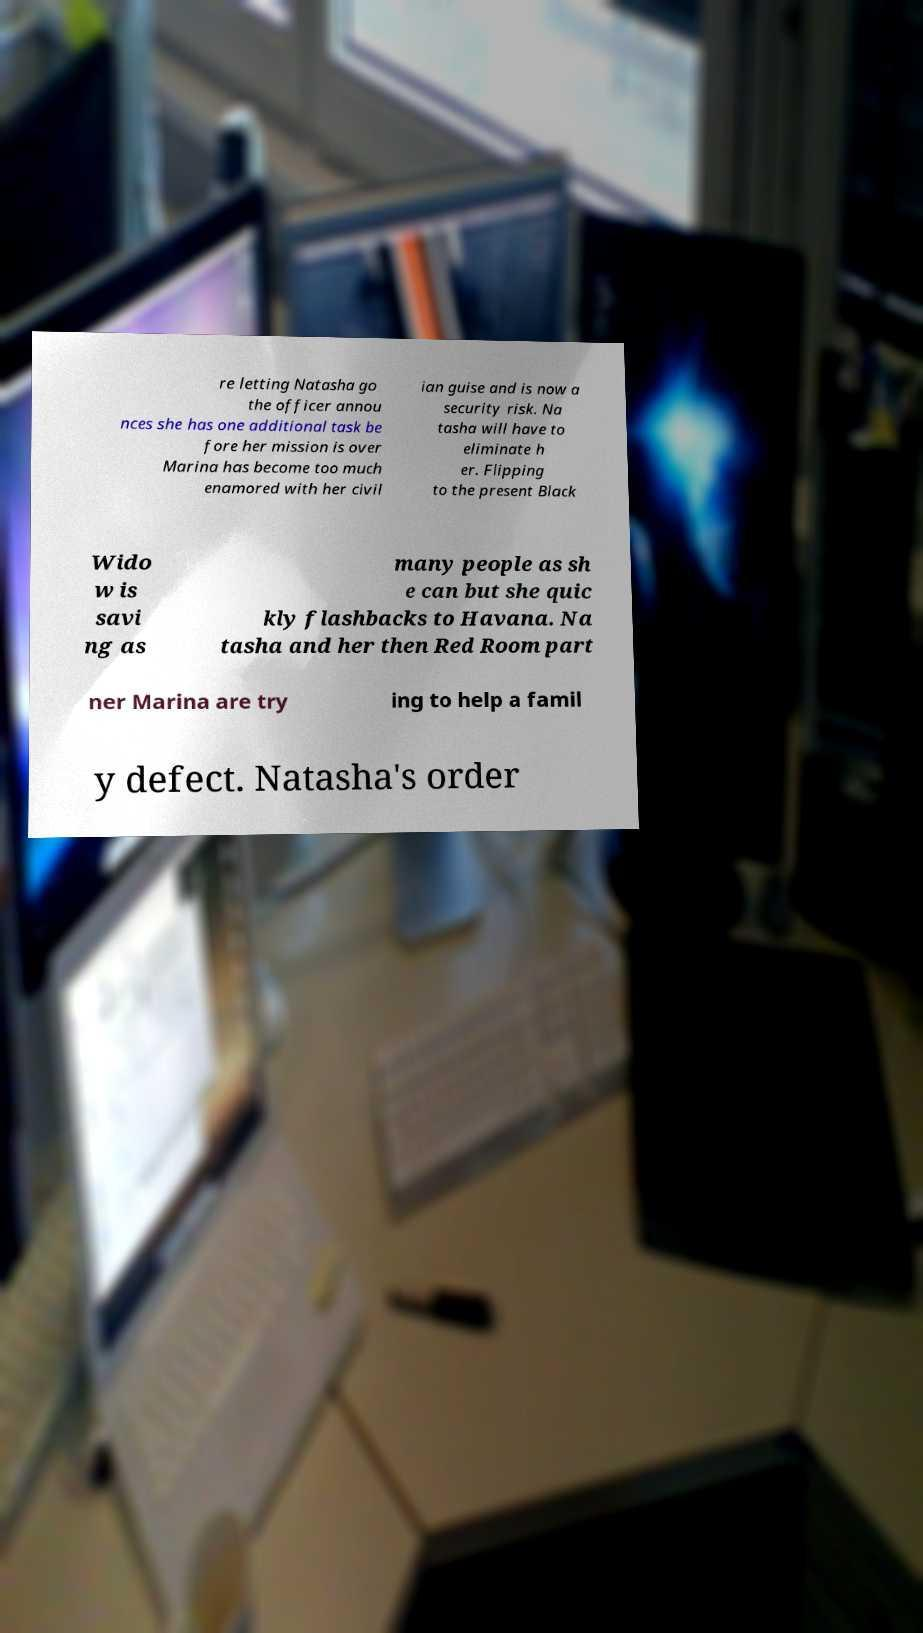What messages or text are displayed in this image? I need them in a readable, typed format. re letting Natasha go the officer annou nces she has one additional task be fore her mission is over Marina has become too much enamored with her civil ian guise and is now a security risk. Na tasha will have to eliminate h er. Flipping to the present Black Wido w is savi ng as many people as sh e can but she quic kly flashbacks to Havana. Na tasha and her then Red Room part ner Marina are try ing to help a famil y defect. Natasha's order 